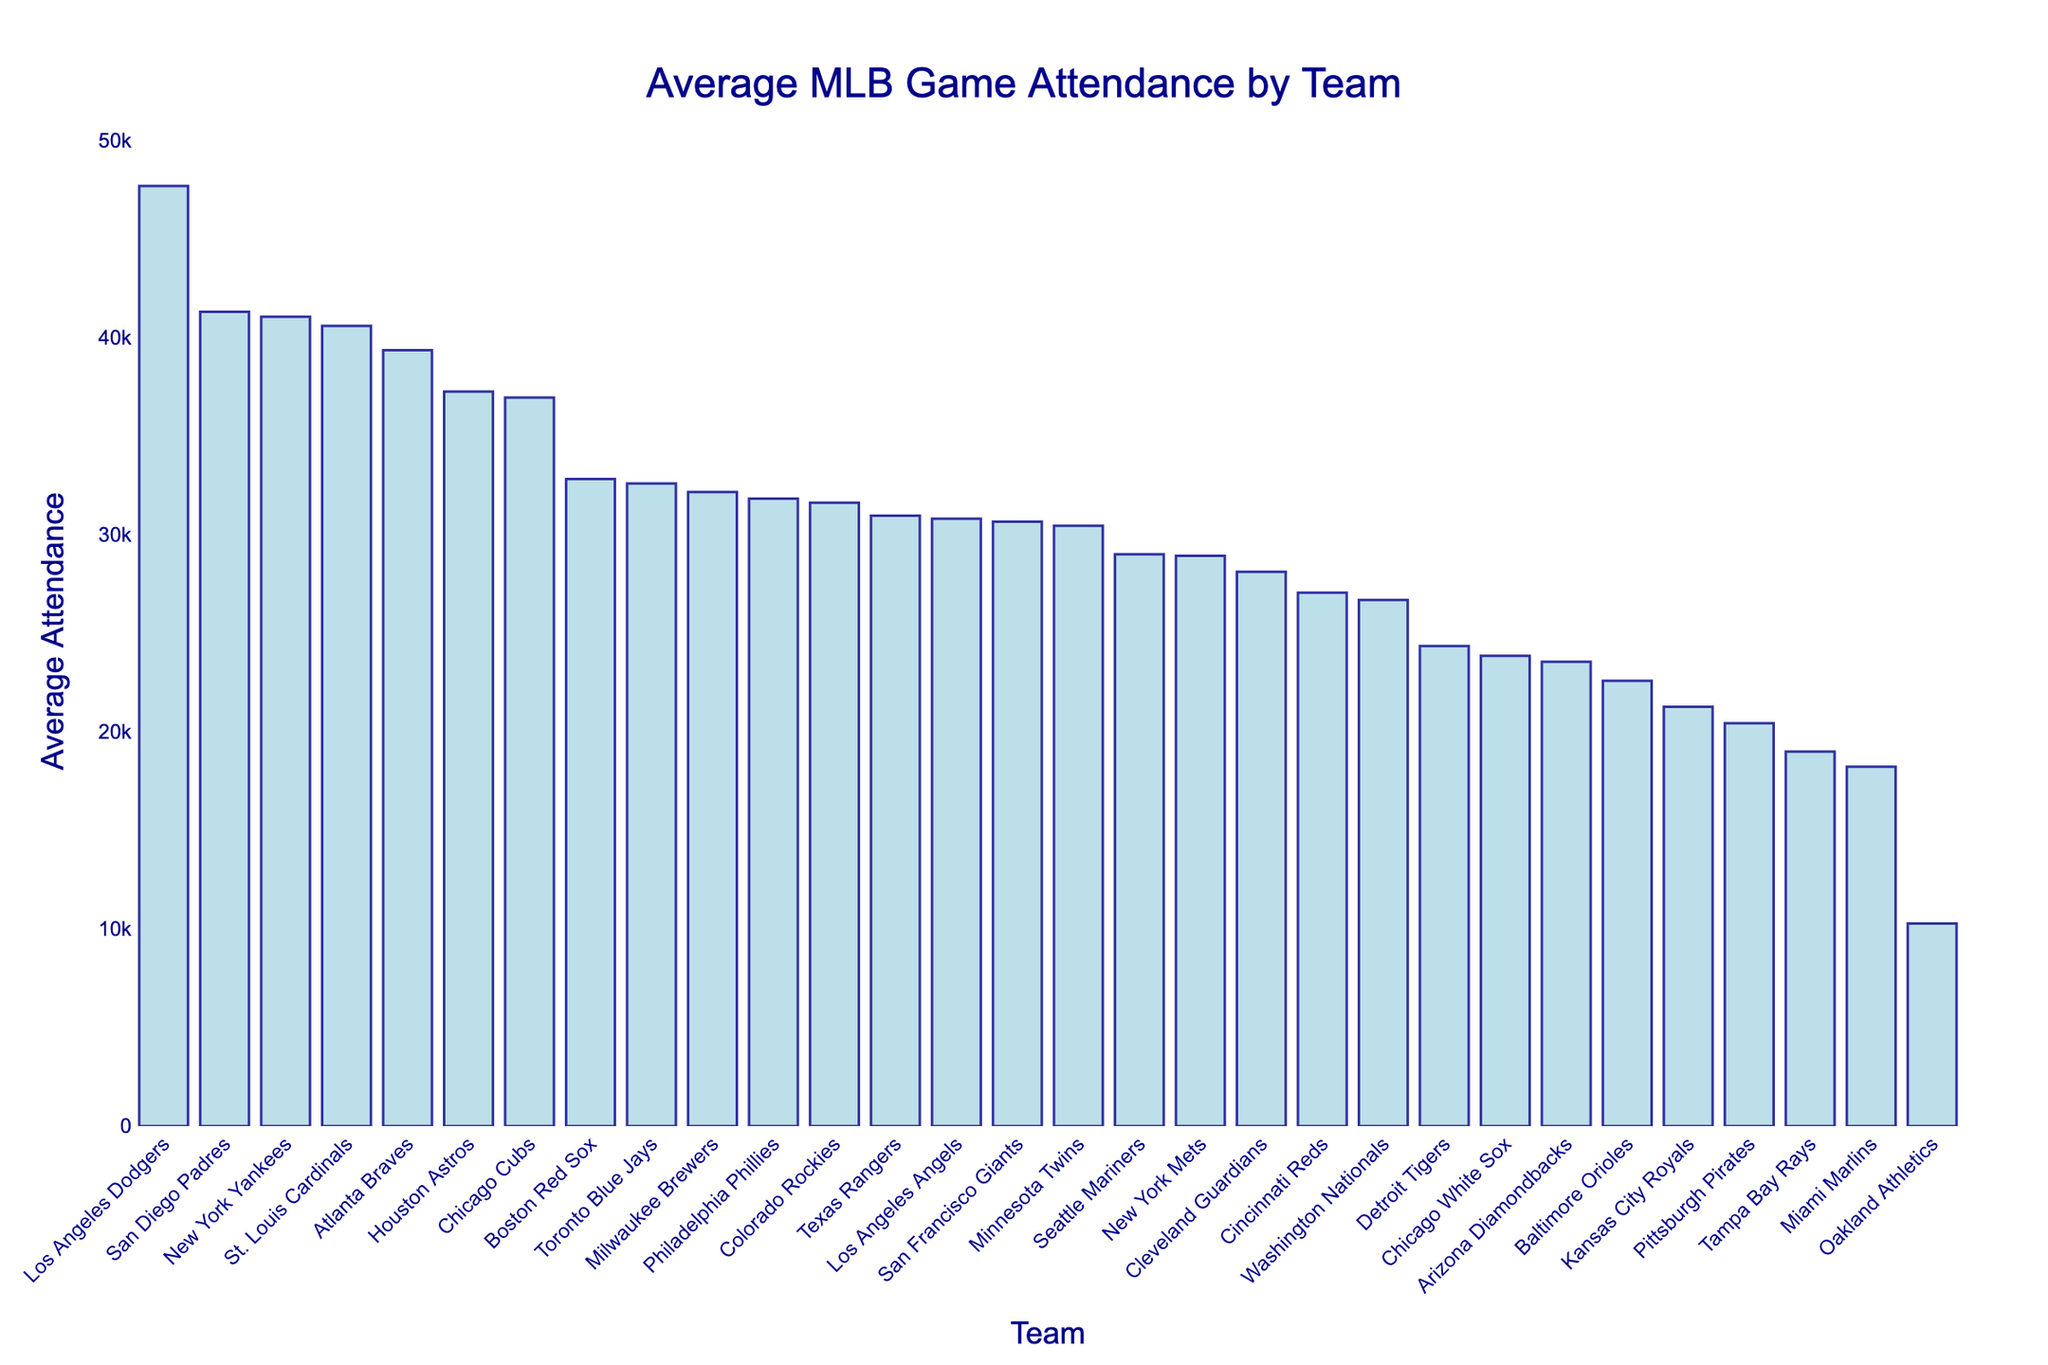What team has the highest average attendance? Look for the tallest bar in the bar chart, which indicates the team with the highest average attendance. The Los Angeles Dodgers have the tallest bar on the figure.
Answer: Los Angeles Dodgers Which team has the lowest average attendance? Look for the shortest bar in the bar chart, which indicates the team with the lowest average attendance. The Oakland Athletics have the shortest bar on the figure.
Answer: Oakland Athletics What is the difference in average attendance between the Los Angeles Dodgers and Oakland Athletics? Find the average attendance values for the Los Angeles Dodgers (47,672) and Oakland Athletics (10,276). Subtract the smaller value from the larger value: 47,672 - 10,276 = 37,396.
Answer: 37,396 How many teams have an average attendance of over 40,000? Count the bars that exceed the 40,000 mark. There are four teams with average attendances above 40,000: Los Angeles Dodgers, San Diego Padres, New York Yankees, and St. Louis Cardinals.
Answer: 4 Which team has a higher average attendance: the New York Yankees or the Houston Astros? Compare the heights of the bars for the New York Yankees (41,041) and Houston Astros (37,242). The New York Yankees' bar is taller.
Answer: New York Yankees Which teams have an average attendance between 30,000 and 35,000? Identify the bars that fall within the range of 30,000 to 35,000. These teams are Boston Red Sox (32,817), Toronto Blue Jays (32,589), Milwaukee Brewers (32,154), Philadelphia Phillies (31,821), Colorado Rockies (31,613), Texas Rangers (30,953), and Los Angeles Angels (30,801).
Answer: Boston Red Sox, Toronto Blue Jays, Milwaukee Brewers, Philadelphia Phillies, Colorado Rockies, Texas Rangers, Los Angeles Angels What is the average attendance for the Chicago teams combined? Find the average attendance for the Chicago Cubs (36,944) and Chicago White Sox (23,843). Add the two values together and divide by 2: (36,944 + 23,843) / 2 = 30,393.5.
Answer: 30,393.5 How much higher is the average attendance of the Atlanta Braves compared to the average attendance of the Seattle Mariners? Find the average attendance for the Atlanta Braves (39,341) and the Seattle Mariners (28,995). Subtract the smaller value from the larger value: 39,341 - 28,995 = 10,346.
Answer: 10,346 Which team ranks 5th in terms of average attendance? Sort the teams by their average attendance in descending order and identify the 5th team. The Atlanta Braves are the 5th team in terms of average attendance with 39,341.
Answer: Atlanta Braves 